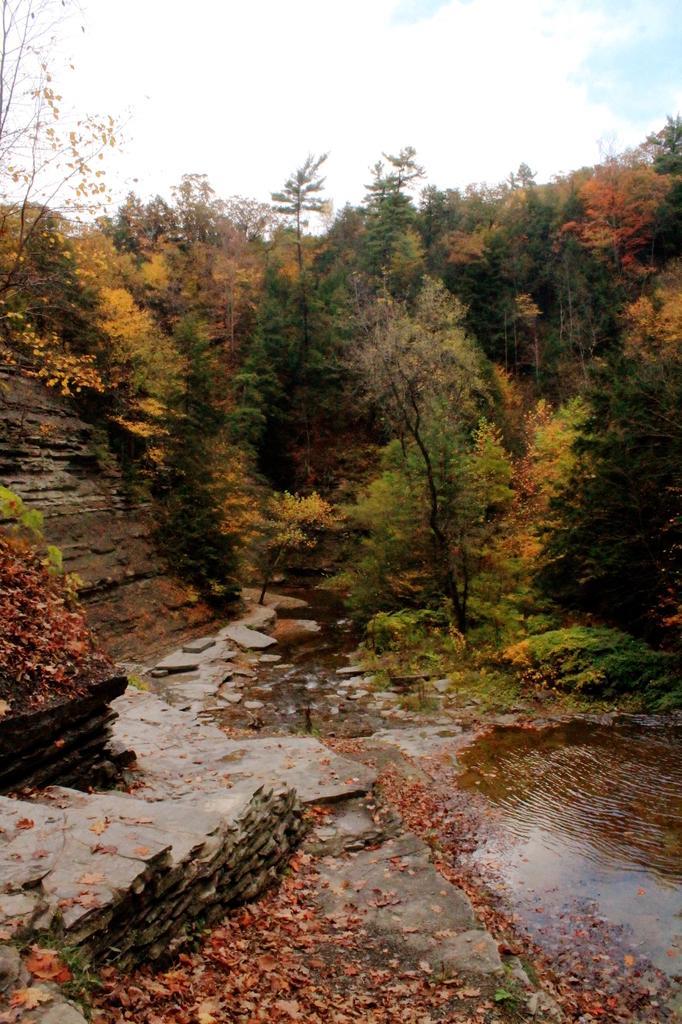Describe this image in one or two sentences. In this image we can see shredded leaves on the ground, water, rocks, trees and sky with clouds in the background. 